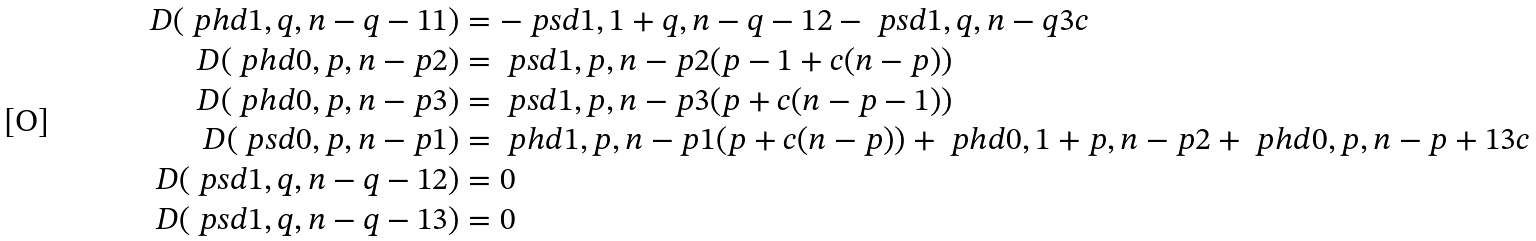<formula> <loc_0><loc_0><loc_500><loc_500>D ( \ p h d { 1 , q , n - q - 1 } 1 ) & = - \ p s d { 1 , 1 + q , n - q - 1 } 2 - \ p s d { 1 , q , n - q } 3 c \\ D ( \ p h d { 0 , p , n - p } 2 ) & = \ p s d { 1 , p , n - p } 2 ( p - 1 + c ( n - p ) ) \\ D ( \ p h d { 0 , p , n - p } 3 ) & = \ p s d { 1 , p , n - p } 3 ( p + c ( n - p - 1 ) ) \\ D ( \ p s d { 0 , p , n - p } 1 ) & = \ p h d { 1 , p , n - p } 1 ( p + c ( n - p ) ) + \ p h d { 0 , 1 + p , n - p } 2 + \ p h d { 0 , p , n - p + 1 } 3 c \\ D ( \ p s d { 1 , q , n - q - 1 } 2 ) & = 0 \\ D ( \ p s d { 1 , q , n - q - 1 } 3 ) & = 0 \\</formula> 